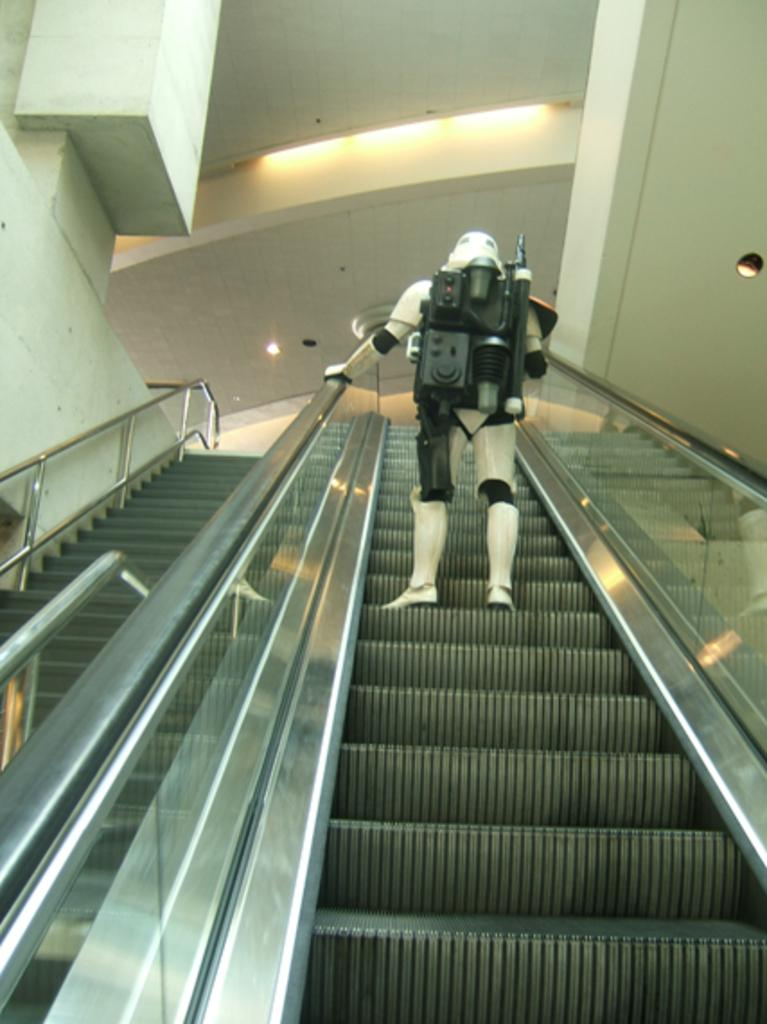What is the person in the image doing? The person is standing on an escalator in the image. What can be seen above the person in the image? The ceiling is visible at the top of the image. Is there any source of illumination in the image? Yes, there is a light in the image. What type of berry can be seen growing on the person's clothing in the image? There are no berries visible on the person's clothing in the image. 